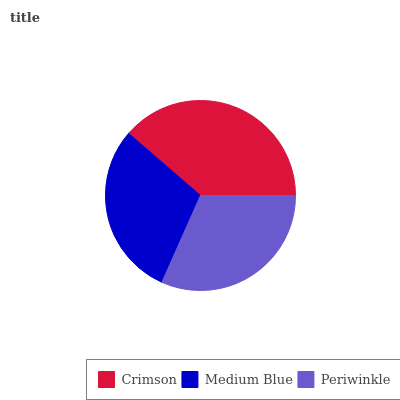Is Medium Blue the minimum?
Answer yes or no. Yes. Is Crimson the maximum?
Answer yes or no. Yes. Is Periwinkle the minimum?
Answer yes or no. No. Is Periwinkle the maximum?
Answer yes or no. No. Is Periwinkle greater than Medium Blue?
Answer yes or no. Yes. Is Medium Blue less than Periwinkle?
Answer yes or no. Yes. Is Medium Blue greater than Periwinkle?
Answer yes or no. No. Is Periwinkle less than Medium Blue?
Answer yes or no. No. Is Periwinkle the high median?
Answer yes or no. Yes. Is Periwinkle the low median?
Answer yes or no. Yes. Is Crimson the high median?
Answer yes or no. No. Is Crimson the low median?
Answer yes or no. No. 